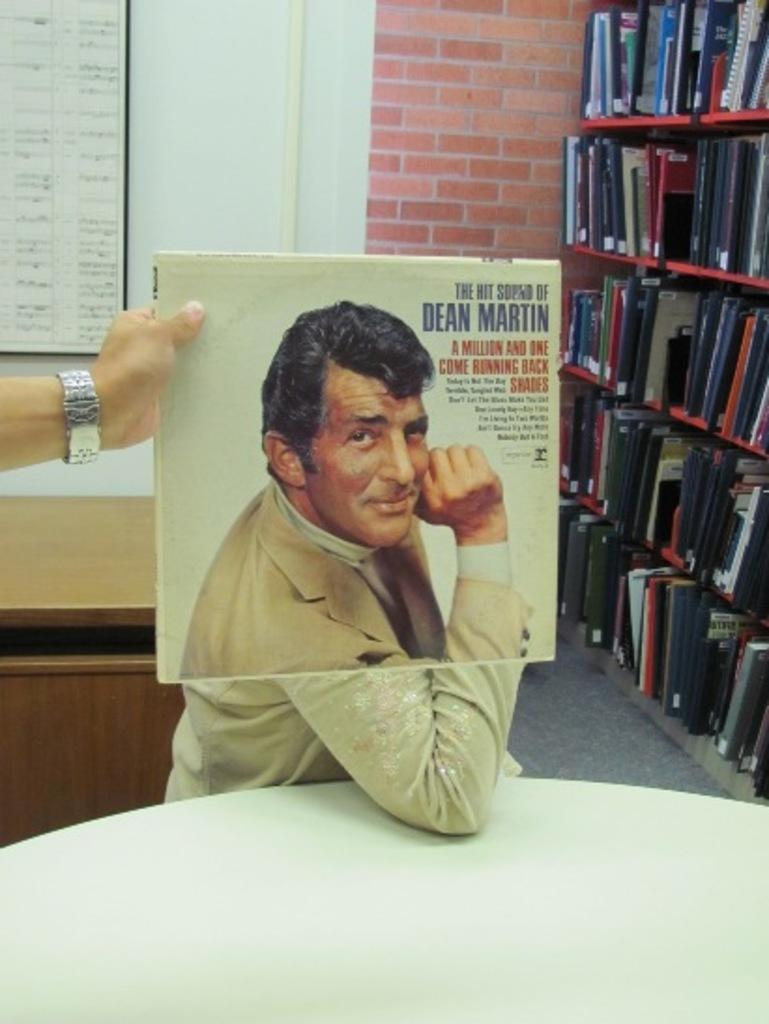<image>
Write a terse but informative summary of the picture. A music album of the hit sound of Dean Martin. 